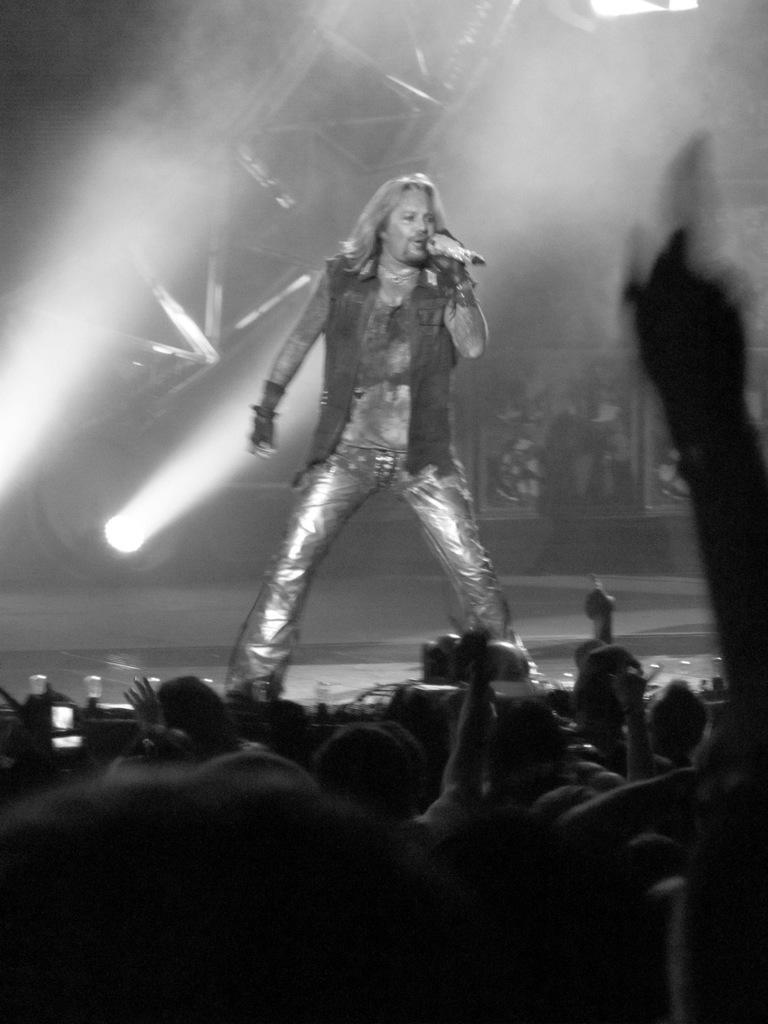How would you summarize this image in a sentence or two? This is a black and white image. This looks like a musical concert. There are some persons at the bottom. There is a person in the middle, who is holding a mic. 